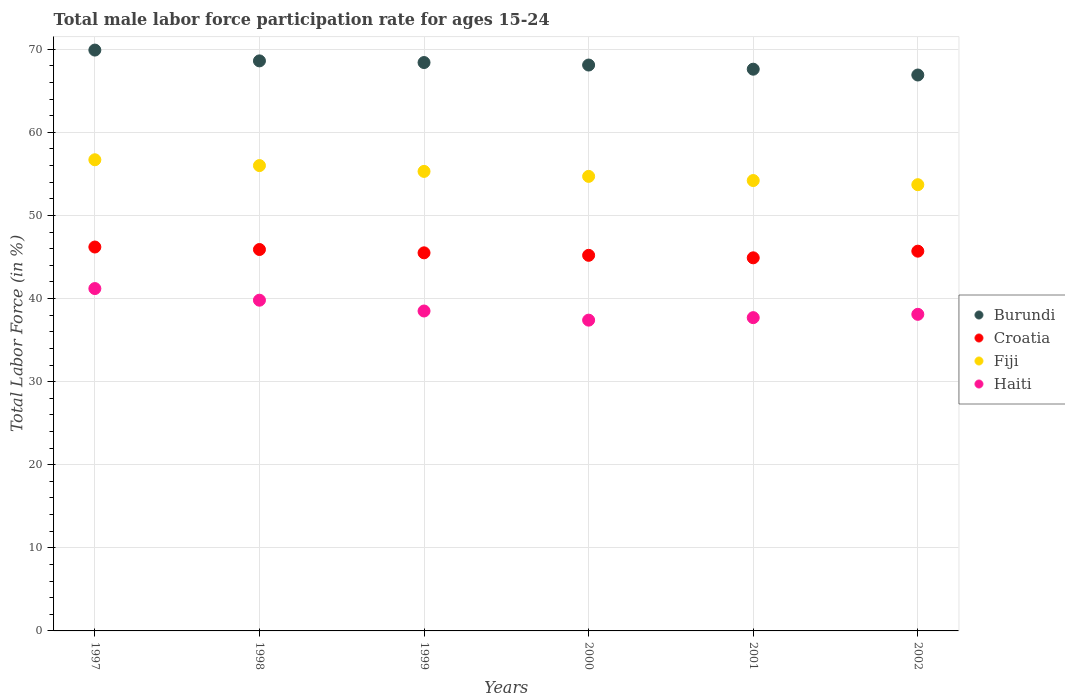What is the male labor force participation rate in Croatia in 2001?
Give a very brief answer. 44.9. Across all years, what is the maximum male labor force participation rate in Haiti?
Your answer should be compact. 41.2. Across all years, what is the minimum male labor force participation rate in Croatia?
Keep it short and to the point. 44.9. In which year was the male labor force participation rate in Fiji minimum?
Your response must be concise. 2002. What is the total male labor force participation rate in Fiji in the graph?
Make the answer very short. 330.6. What is the difference between the male labor force participation rate in Haiti in 1997 and that in 2000?
Provide a short and direct response. 3.8. What is the difference between the male labor force participation rate in Croatia in 2002 and the male labor force participation rate in Haiti in 1999?
Offer a very short reply. 7.2. What is the average male labor force participation rate in Burundi per year?
Provide a short and direct response. 68.25. In the year 2000, what is the difference between the male labor force participation rate in Haiti and male labor force participation rate in Croatia?
Provide a short and direct response. -7.8. What is the ratio of the male labor force participation rate in Haiti in 1997 to that in 1998?
Provide a succinct answer. 1.04. Is the difference between the male labor force participation rate in Haiti in 1999 and 2001 greater than the difference between the male labor force participation rate in Croatia in 1999 and 2001?
Offer a terse response. Yes. What is the difference between the highest and the second highest male labor force participation rate in Burundi?
Your answer should be compact. 1.3. What is the difference between the highest and the lowest male labor force participation rate in Burundi?
Make the answer very short. 3. In how many years, is the male labor force participation rate in Burundi greater than the average male labor force participation rate in Burundi taken over all years?
Your answer should be very brief. 3. Is the sum of the male labor force participation rate in Croatia in 1997 and 2000 greater than the maximum male labor force participation rate in Burundi across all years?
Your response must be concise. Yes. Does the male labor force participation rate in Burundi monotonically increase over the years?
Your answer should be compact. No. What is the difference between two consecutive major ticks on the Y-axis?
Your answer should be very brief. 10. How many legend labels are there?
Keep it short and to the point. 4. What is the title of the graph?
Make the answer very short. Total male labor force participation rate for ages 15-24. Does "Puerto Rico" appear as one of the legend labels in the graph?
Your answer should be compact. No. What is the label or title of the X-axis?
Provide a short and direct response. Years. What is the label or title of the Y-axis?
Keep it short and to the point. Total Labor Force (in %). What is the Total Labor Force (in %) of Burundi in 1997?
Provide a short and direct response. 69.9. What is the Total Labor Force (in %) in Croatia in 1997?
Keep it short and to the point. 46.2. What is the Total Labor Force (in %) of Fiji in 1997?
Provide a succinct answer. 56.7. What is the Total Labor Force (in %) in Haiti in 1997?
Provide a succinct answer. 41.2. What is the Total Labor Force (in %) of Burundi in 1998?
Ensure brevity in your answer.  68.6. What is the Total Labor Force (in %) in Croatia in 1998?
Offer a very short reply. 45.9. What is the Total Labor Force (in %) in Haiti in 1998?
Provide a succinct answer. 39.8. What is the Total Labor Force (in %) in Burundi in 1999?
Provide a succinct answer. 68.4. What is the Total Labor Force (in %) in Croatia in 1999?
Offer a very short reply. 45.5. What is the Total Labor Force (in %) in Fiji in 1999?
Keep it short and to the point. 55.3. What is the Total Labor Force (in %) in Haiti in 1999?
Make the answer very short. 38.5. What is the Total Labor Force (in %) of Burundi in 2000?
Make the answer very short. 68.1. What is the Total Labor Force (in %) in Croatia in 2000?
Offer a terse response. 45.2. What is the Total Labor Force (in %) in Fiji in 2000?
Offer a terse response. 54.7. What is the Total Labor Force (in %) in Haiti in 2000?
Give a very brief answer. 37.4. What is the Total Labor Force (in %) in Burundi in 2001?
Your answer should be compact. 67.6. What is the Total Labor Force (in %) of Croatia in 2001?
Keep it short and to the point. 44.9. What is the Total Labor Force (in %) in Fiji in 2001?
Provide a short and direct response. 54.2. What is the Total Labor Force (in %) of Haiti in 2001?
Offer a very short reply. 37.7. What is the Total Labor Force (in %) of Burundi in 2002?
Your answer should be very brief. 66.9. What is the Total Labor Force (in %) in Croatia in 2002?
Your answer should be very brief. 45.7. What is the Total Labor Force (in %) of Fiji in 2002?
Provide a succinct answer. 53.7. What is the Total Labor Force (in %) of Haiti in 2002?
Your answer should be very brief. 38.1. Across all years, what is the maximum Total Labor Force (in %) in Burundi?
Make the answer very short. 69.9. Across all years, what is the maximum Total Labor Force (in %) of Croatia?
Give a very brief answer. 46.2. Across all years, what is the maximum Total Labor Force (in %) of Fiji?
Your answer should be compact. 56.7. Across all years, what is the maximum Total Labor Force (in %) of Haiti?
Make the answer very short. 41.2. Across all years, what is the minimum Total Labor Force (in %) in Burundi?
Offer a terse response. 66.9. Across all years, what is the minimum Total Labor Force (in %) of Croatia?
Ensure brevity in your answer.  44.9. Across all years, what is the minimum Total Labor Force (in %) in Fiji?
Provide a succinct answer. 53.7. Across all years, what is the minimum Total Labor Force (in %) in Haiti?
Offer a very short reply. 37.4. What is the total Total Labor Force (in %) in Burundi in the graph?
Provide a short and direct response. 409.5. What is the total Total Labor Force (in %) of Croatia in the graph?
Your answer should be very brief. 273.4. What is the total Total Labor Force (in %) of Fiji in the graph?
Provide a succinct answer. 330.6. What is the total Total Labor Force (in %) in Haiti in the graph?
Offer a terse response. 232.7. What is the difference between the Total Labor Force (in %) in Burundi in 1997 and that in 1998?
Give a very brief answer. 1.3. What is the difference between the Total Labor Force (in %) in Haiti in 1997 and that in 1998?
Keep it short and to the point. 1.4. What is the difference between the Total Labor Force (in %) of Haiti in 1997 and that in 1999?
Keep it short and to the point. 2.7. What is the difference between the Total Labor Force (in %) of Croatia in 1997 and that in 2000?
Your response must be concise. 1. What is the difference between the Total Labor Force (in %) in Haiti in 1997 and that in 2000?
Provide a short and direct response. 3.8. What is the difference between the Total Labor Force (in %) of Fiji in 1997 and that in 2001?
Provide a succinct answer. 2.5. What is the difference between the Total Labor Force (in %) of Burundi in 1997 and that in 2002?
Provide a short and direct response. 3. What is the difference between the Total Labor Force (in %) of Burundi in 1998 and that in 1999?
Offer a very short reply. 0.2. What is the difference between the Total Labor Force (in %) of Fiji in 1998 and that in 1999?
Offer a terse response. 0.7. What is the difference between the Total Labor Force (in %) in Haiti in 1998 and that in 1999?
Provide a succinct answer. 1.3. What is the difference between the Total Labor Force (in %) in Croatia in 1998 and that in 2000?
Offer a terse response. 0.7. What is the difference between the Total Labor Force (in %) in Fiji in 1998 and that in 2001?
Offer a terse response. 1.8. What is the difference between the Total Labor Force (in %) of Haiti in 1998 and that in 2002?
Provide a short and direct response. 1.7. What is the difference between the Total Labor Force (in %) of Burundi in 1999 and that in 2000?
Offer a terse response. 0.3. What is the difference between the Total Labor Force (in %) of Fiji in 1999 and that in 2000?
Offer a terse response. 0.6. What is the difference between the Total Labor Force (in %) of Haiti in 1999 and that in 2000?
Your response must be concise. 1.1. What is the difference between the Total Labor Force (in %) of Haiti in 1999 and that in 2001?
Provide a short and direct response. 0.8. What is the difference between the Total Labor Force (in %) of Burundi in 1999 and that in 2002?
Offer a terse response. 1.5. What is the difference between the Total Labor Force (in %) in Haiti in 1999 and that in 2002?
Make the answer very short. 0.4. What is the difference between the Total Labor Force (in %) of Haiti in 2000 and that in 2001?
Your answer should be compact. -0.3. What is the difference between the Total Labor Force (in %) in Burundi in 2000 and that in 2002?
Give a very brief answer. 1.2. What is the difference between the Total Labor Force (in %) in Burundi in 2001 and that in 2002?
Your response must be concise. 0.7. What is the difference between the Total Labor Force (in %) in Croatia in 2001 and that in 2002?
Provide a short and direct response. -0.8. What is the difference between the Total Labor Force (in %) of Haiti in 2001 and that in 2002?
Make the answer very short. -0.4. What is the difference between the Total Labor Force (in %) of Burundi in 1997 and the Total Labor Force (in %) of Haiti in 1998?
Keep it short and to the point. 30.1. What is the difference between the Total Labor Force (in %) of Croatia in 1997 and the Total Labor Force (in %) of Haiti in 1998?
Give a very brief answer. 6.4. What is the difference between the Total Labor Force (in %) of Fiji in 1997 and the Total Labor Force (in %) of Haiti in 1998?
Ensure brevity in your answer.  16.9. What is the difference between the Total Labor Force (in %) in Burundi in 1997 and the Total Labor Force (in %) in Croatia in 1999?
Your answer should be very brief. 24.4. What is the difference between the Total Labor Force (in %) in Burundi in 1997 and the Total Labor Force (in %) in Haiti in 1999?
Provide a succinct answer. 31.4. What is the difference between the Total Labor Force (in %) in Croatia in 1997 and the Total Labor Force (in %) in Haiti in 1999?
Keep it short and to the point. 7.7. What is the difference between the Total Labor Force (in %) of Burundi in 1997 and the Total Labor Force (in %) of Croatia in 2000?
Ensure brevity in your answer.  24.7. What is the difference between the Total Labor Force (in %) in Burundi in 1997 and the Total Labor Force (in %) in Haiti in 2000?
Make the answer very short. 32.5. What is the difference between the Total Labor Force (in %) of Croatia in 1997 and the Total Labor Force (in %) of Haiti in 2000?
Give a very brief answer. 8.8. What is the difference between the Total Labor Force (in %) of Fiji in 1997 and the Total Labor Force (in %) of Haiti in 2000?
Offer a very short reply. 19.3. What is the difference between the Total Labor Force (in %) of Burundi in 1997 and the Total Labor Force (in %) of Fiji in 2001?
Provide a short and direct response. 15.7. What is the difference between the Total Labor Force (in %) in Burundi in 1997 and the Total Labor Force (in %) in Haiti in 2001?
Ensure brevity in your answer.  32.2. What is the difference between the Total Labor Force (in %) of Croatia in 1997 and the Total Labor Force (in %) of Fiji in 2001?
Your answer should be compact. -8. What is the difference between the Total Labor Force (in %) in Croatia in 1997 and the Total Labor Force (in %) in Haiti in 2001?
Make the answer very short. 8.5. What is the difference between the Total Labor Force (in %) of Fiji in 1997 and the Total Labor Force (in %) of Haiti in 2001?
Keep it short and to the point. 19. What is the difference between the Total Labor Force (in %) of Burundi in 1997 and the Total Labor Force (in %) of Croatia in 2002?
Provide a short and direct response. 24.2. What is the difference between the Total Labor Force (in %) in Burundi in 1997 and the Total Labor Force (in %) in Fiji in 2002?
Keep it short and to the point. 16.2. What is the difference between the Total Labor Force (in %) in Burundi in 1997 and the Total Labor Force (in %) in Haiti in 2002?
Keep it short and to the point. 31.8. What is the difference between the Total Labor Force (in %) in Croatia in 1997 and the Total Labor Force (in %) in Haiti in 2002?
Provide a succinct answer. 8.1. What is the difference between the Total Labor Force (in %) of Fiji in 1997 and the Total Labor Force (in %) of Haiti in 2002?
Keep it short and to the point. 18.6. What is the difference between the Total Labor Force (in %) of Burundi in 1998 and the Total Labor Force (in %) of Croatia in 1999?
Ensure brevity in your answer.  23.1. What is the difference between the Total Labor Force (in %) of Burundi in 1998 and the Total Labor Force (in %) of Haiti in 1999?
Keep it short and to the point. 30.1. What is the difference between the Total Labor Force (in %) of Croatia in 1998 and the Total Labor Force (in %) of Haiti in 1999?
Ensure brevity in your answer.  7.4. What is the difference between the Total Labor Force (in %) of Burundi in 1998 and the Total Labor Force (in %) of Croatia in 2000?
Your answer should be very brief. 23.4. What is the difference between the Total Labor Force (in %) of Burundi in 1998 and the Total Labor Force (in %) of Fiji in 2000?
Offer a very short reply. 13.9. What is the difference between the Total Labor Force (in %) of Burundi in 1998 and the Total Labor Force (in %) of Haiti in 2000?
Offer a very short reply. 31.2. What is the difference between the Total Labor Force (in %) in Croatia in 1998 and the Total Labor Force (in %) in Haiti in 2000?
Your answer should be compact. 8.5. What is the difference between the Total Labor Force (in %) in Fiji in 1998 and the Total Labor Force (in %) in Haiti in 2000?
Offer a terse response. 18.6. What is the difference between the Total Labor Force (in %) in Burundi in 1998 and the Total Labor Force (in %) in Croatia in 2001?
Give a very brief answer. 23.7. What is the difference between the Total Labor Force (in %) in Burundi in 1998 and the Total Labor Force (in %) in Fiji in 2001?
Ensure brevity in your answer.  14.4. What is the difference between the Total Labor Force (in %) of Burundi in 1998 and the Total Labor Force (in %) of Haiti in 2001?
Provide a succinct answer. 30.9. What is the difference between the Total Labor Force (in %) in Croatia in 1998 and the Total Labor Force (in %) in Haiti in 2001?
Make the answer very short. 8.2. What is the difference between the Total Labor Force (in %) in Burundi in 1998 and the Total Labor Force (in %) in Croatia in 2002?
Keep it short and to the point. 22.9. What is the difference between the Total Labor Force (in %) in Burundi in 1998 and the Total Labor Force (in %) in Haiti in 2002?
Keep it short and to the point. 30.5. What is the difference between the Total Labor Force (in %) of Croatia in 1998 and the Total Labor Force (in %) of Fiji in 2002?
Provide a succinct answer. -7.8. What is the difference between the Total Labor Force (in %) in Fiji in 1998 and the Total Labor Force (in %) in Haiti in 2002?
Keep it short and to the point. 17.9. What is the difference between the Total Labor Force (in %) of Burundi in 1999 and the Total Labor Force (in %) of Croatia in 2000?
Your response must be concise. 23.2. What is the difference between the Total Labor Force (in %) in Fiji in 1999 and the Total Labor Force (in %) in Haiti in 2000?
Your answer should be very brief. 17.9. What is the difference between the Total Labor Force (in %) of Burundi in 1999 and the Total Labor Force (in %) of Croatia in 2001?
Your answer should be very brief. 23.5. What is the difference between the Total Labor Force (in %) of Burundi in 1999 and the Total Labor Force (in %) of Fiji in 2001?
Offer a terse response. 14.2. What is the difference between the Total Labor Force (in %) of Burundi in 1999 and the Total Labor Force (in %) of Haiti in 2001?
Your answer should be very brief. 30.7. What is the difference between the Total Labor Force (in %) of Croatia in 1999 and the Total Labor Force (in %) of Haiti in 2001?
Make the answer very short. 7.8. What is the difference between the Total Labor Force (in %) in Fiji in 1999 and the Total Labor Force (in %) in Haiti in 2001?
Make the answer very short. 17.6. What is the difference between the Total Labor Force (in %) in Burundi in 1999 and the Total Labor Force (in %) in Croatia in 2002?
Provide a short and direct response. 22.7. What is the difference between the Total Labor Force (in %) in Burundi in 1999 and the Total Labor Force (in %) in Haiti in 2002?
Provide a succinct answer. 30.3. What is the difference between the Total Labor Force (in %) of Burundi in 2000 and the Total Labor Force (in %) of Croatia in 2001?
Make the answer very short. 23.2. What is the difference between the Total Labor Force (in %) of Burundi in 2000 and the Total Labor Force (in %) of Haiti in 2001?
Make the answer very short. 30.4. What is the difference between the Total Labor Force (in %) in Croatia in 2000 and the Total Labor Force (in %) in Fiji in 2001?
Ensure brevity in your answer.  -9. What is the difference between the Total Labor Force (in %) in Croatia in 2000 and the Total Labor Force (in %) in Haiti in 2001?
Provide a succinct answer. 7.5. What is the difference between the Total Labor Force (in %) in Burundi in 2000 and the Total Labor Force (in %) in Croatia in 2002?
Keep it short and to the point. 22.4. What is the difference between the Total Labor Force (in %) in Burundi in 2000 and the Total Labor Force (in %) in Fiji in 2002?
Make the answer very short. 14.4. What is the difference between the Total Labor Force (in %) in Burundi in 2000 and the Total Labor Force (in %) in Haiti in 2002?
Your answer should be very brief. 30. What is the difference between the Total Labor Force (in %) in Burundi in 2001 and the Total Labor Force (in %) in Croatia in 2002?
Your answer should be very brief. 21.9. What is the difference between the Total Labor Force (in %) of Burundi in 2001 and the Total Labor Force (in %) of Haiti in 2002?
Provide a short and direct response. 29.5. What is the difference between the Total Labor Force (in %) in Croatia in 2001 and the Total Labor Force (in %) in Fiji in 2002?
Your response must be concise. -8.8. What is the average Total Labor Force (in %) in Burundi per year?
Make the answer very short. 68.25. What is the average Total Labor Force (in %) of Croatia per year?
Your answer should be very brief. 45.57. What is the average Total Labor Force (in %) of Fiji per year?
Offer a terse response. 55.1. What is the average Total Labor Force (in %) of Haiti per year?
Provide a short and direct response. 38.78. In the year 1997, what is the difference between the Total Labor Force (in %) in Burundi and Total Labor Force (in %) in Croatia?
Offer a terse response. 23.7. In the year 1997, what is the difference between the Total Labor Force (in %) in Burundi and Total Labor Force (in %) in Haiti?
Your response must be concise. 28.7. In the year 1997, what is the difference between the Total Labor Force (in %) of Croatia and Total Labor Force (in %) of Fiji?
Offer a terse response. -10.5. In the year 1997, what is the difference between the Total Labor Force (in %) of Croatia and Total Labor Force (in %) of Haiti?
Give a very brief answer. 5. In the year 1998, what is the difference between the Total Labor Force (in %) of Burundi and Total Labor Force (in %) of Croatia?
Your response must be concise. 22.7. In the year 1998, what is the difference between the Total Labor Force (in %) in Burundi and Total Labor Force (in %) in Fiji?
Ensure brevity in your answer.  12.6. In the year 1998, what is the difference between the Total Labor Force (in %) of Burundi and Total Labor Force (in %) of Haiti?
Keep it short and to the point. 28.8. In the year 1998, what is the difference between the Total Labor Force (in %) of Croatia and Total Labor Force (in %) of Fiji?
Keep it short and to the point. -10.1. In the year 1998, what is the difference between the Total Labor Force (in %) in Croatia and Total Labor Force (in %) in Haiti?
Make the answer very short. 6.1. In the year 1999, what is the difference between the Total Labor Force (in %) in Burundi and Total Labor Force (in %) in Croatia?
Provide a succinct answer. 22.9. In the year 1999, what is the difference between the Total Labor Force (in %) in Burundi and Total Labor Force (in %) in Fiji?
Provide a succinct answer. 13.1. In the year 1999, what is the difference between the Total Labor Force (in %) in Burundi and Total Labor Force (in %) in Haiti?
Your answer should be compact. 29.9. In the year 1999, what is the difference between the Total Labor Force (in %) of Croatia and Total Labor Force (in %) of Fiji?
Your answer should be compact. -9.8. In the year 1999, what is the difference between the Total Labor Force (in %) in Fiji and Total Labor Force (in %) in Haiti?
Make the answer very short. 16.8. In the year 2000, what is the difference between the Total Labor Force (in %) of Burundi and Total Labor Force (in %) of Croatia?
Your answer should be very brief. 22.9. In the year 2000, what is the difference between the Total Labor Force (in %) of Burundi and Total Labor Force (in %) of Fiji?
Ensure brevity in your answer.  13.4. In the year 2000, what is the difference between the Total Labor Force (in %) of Burundi and Total Labor Force (in %) of Haiti?
Give a very brief answer. 30.7. In the year 2000, what is the difference between the Total Labor Force (in %) of Croatia and Total Labor Force (in %) of Haiti?
Give a very brief answer. 7.8. In the year 2001, what is the difference between the Total Labor Force (in %) in Burundi and Total Labor Force (in %) in Croatia?
Provide a succinct answer. 22.7. In the year 2001, what is the difference between the Total Labor Force (in %) of Burundi and Total Labor Force (in %) of Fiji?
Your answer should be compact. 13.4. In the year 2001, what is the difference between the Total Labor Force (in %) of Burundi and Total Labor Force (in %) of Haiti?
Ensure brevity in your answer.  29.9. In the year 2001, what is the difference between the Total Labor Force (in %) of Croatia and Total Labor Force (in %) of Fiji?
Provide a succinct answer. -9.3. In the year 2002, what is the difference between the Total Labor Force (in %) in Burundi and Total Labor Force (in %) in Croatia?
Your response must be concise. 21.2. In the year 2002, what is the difference between the Total Labor Force (in %) in Burundi and Total Labor Force (in %) in Fiji?
Provide a short and direct response. 13.2. In the year 2002, what is the difference between the Total Labor Force (in %) in Burundi and Total Labor Force (in %) in Haiti?
Ensure brevity in your answer.  28.8. In the year 2002, what is the difference between the Total Labor Force (in %) of Fiji and Total Labor Force (in %) of Haiti?
Ensure brevity in your answer.  15.6. What is the ratio of the Total Labor Force (in %) in Croatia in 1997 to that in 1998?
Your answer should be very brief. 1.01. What is the ratio of the Total Labor Force (in %) in Fiji in 1997 to that in 1998?
Ensure brevity in your answer.  1.01. What is the ratio of the Total Labor Force (in %) in Haiti in 1997 to that in 1998?
Your answer should be very brief. 1.04. What is the ratio of the Total Labor Force (in %) of Burundi in 1997 to that in 1999?
Provide a succinct answer. 1.02. What is the ratio of the Total Labor Force (in %) in Croatia in 1997 to that in 1999?
Provide a short and direct response. 1.02. What is the ratio of the Total Labor Force (in %) of Fiji in 1997 to that in 1999?
Provide a succinct answer. 1.03. What is the ratio of the Total Labor Force (in %) in Haiti in 1997 to that in 1999?
Ensure brevity in your answer.  1.07. What is the ratio of the Total Labor Force (in %) of Burundi in 1997 to that in 2000?
Provide a short and direct response. 1.03. What is the ratio of the Total Labor Force (in %) in Croatia in 1997 to that in 2000?
Offer a very short reply. 1.02. What is the ratio of the Total Labor Force (in %) in Fiji in 1997 to that in 2000?
Make the answer very short. 1.04. What is the ratio of the Total Labor Force (in %) in Haiti in 1997 to that in 2000?
Your answer should be very brief. 1.1. What is the ratio of the Total Labor Force (in %) in Burundi in 1997 to that in 2001?
Your answer should be compact. 1.03. What is the ratio of the Total Labor Force (in %) in Fiji in 1997 to that in 2001?
Make the answer very short. 1.05. What is the ratio of the Total Labor Force (in %) in Haiti in 1997 to that in 2001?
Make the answer very short. 1.09. What is the ratio of the Total Labor Force (in %) in Burundi in 1997 to that in 2002?
Your answer should be compact. 1.04. What is the ratio of the Total Labor Force (in %) in Croatia in 1997 to that in 2002?
Your response must be concise. 1.01. What is the ratio of the Total Labor Force (in %) in Fiji in 1997 to that in 2002?
Provide a succinct answer. 1.06. What is the ratio of the Total Labor Force (in %) of Haiti in 1997 to that in 2002?
Your response must be concise. 1.08. What is the ratio of the Total Labor Force (in %) in Croatia in 1998 to that in 1999?
Make the answer very short. 1.01. What is the ratio of the Total Labor Force (in %) of Fiji in 1998 to that in 1999?
Give a very brief answer. 1.01. What is the ratio of the Total Labor Force (in %) of Haiti in 1998 to that in 1999?
Your answer should be compact. 1.03. What is the ratio of the Total Labor Force (in %) of Burundi in 1998 to that in 2000?
Your response must be concise. 1.01. What is the ratio of the Total Labor Force (in %) in Croatia in 1998 to that in 2000?
Your answer should be very brief. 1.02. What is the ratio of the Total Labor Force (in %) in Fiji in 1998 to that in 2000?
Offer a very short reply. 1.02. What is the ratio of the Total Labor Force (in %) of Haiti in 1998 to that in 2000?
Provide a short and direct response. 1.06. What is the ratio of the Total Labor Force (in %) of Burundi in 1998 to that in 2001?
Ensure brevity in your answer.  1.01. What is the ratio of the Total Labor Force (in %) in Croatia in 1998 to that in 2001?
Make the answer very short. 1.02. What is the ratio of the Total Labor Force (in %) in Fiji in 1998 to that in 2001?
Your answer should be compact. 1.03. What is the ratio of the Total Labor Force (in %) of Haiti in 1998 to that in 2001?
Ensure brevity in your answer.  1.06. What is the ratio of the Total Labor Force (in %) in Burundi in 1998 to that in 2002?
Provide a succinct answer. 1.03. What is the ratio of the Total Labor Force (in %) in Fiji in 1998 to that in 2002?
Provide a short and direct response. 1.04. What is the ratio of the Total Labor Force (in %) in Haiti in 1998 to that in 2002?
Your response must be concise. 1.04. What is the ratio of the Total Labor Force (in %) in Croatia in 1999 to that in 2000?
Ensure brevity in your answer.  1.01. What is the ratio of the Total Labor Force (in %) of Fiji in 1999 to that in 2000?
Your answer should be compact. 1.01. What is the ratio of the Total Labor Force (in %) of Haiti in 1999 to that in 2000?
Make the answer very short. 1.03. What is the ratio of the Total Labor Force (in %) of Burundi in 1999 to that in 2001?
Provide a succinct answer. 1.01. What is the ratio of the Total Labor Force (in %) in Croatia in 1999 to that in 2001?
Your response must be concise. 1.01. What is the ratio of the Total Labor Force (in %) of Fiji in 1999 to that in 2001?
Keep it short and to the point. 1.02. What is the ratio of the Total Labor Force (in %) in Haiti in 1999 to that in 2001?
Offer a terse response. 1.02. What is the ratio of the Total Labor Force (in %) in Burundi in 1999 to that in 2002?
Offer a very short reply. 1.02. What is the ratio of the Total Labor Force (in %) of Croatia in 1999 to that in 2002?
Ensure brevity in your answer.  1. What is the ratio of the Total Labor Force (in %) of Fiji in 1999 to that in 2002?
Ensure brevity in your answer.  1.03. What is the ratio of the Total Labor Force (in %) in Haiti in 1999 to that in 2002?
Ensure brevity in your answer.  1.01. What is the ratio of the Total Labor Force (in %) of Burundi in 2000 to that in 2001?
Provide a short and direct response. 1.01. What is the ratio of the Total Labor Force (in %) in Croatia in 2000 to that in 2001?
Your answer should be very brief. 1.01. What is the ratio of the Total Labor Force (in %) in Fiji in 2000 to that in 2001?
Offer a very short reply. 1.01. What is the ratio of the Total Labor Force (in %) in Haiti in 2000 to that in 2001?
Ensure brevity in your answer.  0.99. What is the ratio of the Total Labor Force (in %) in Burundi in 2000 to that in 2002?
Make the answer very short. 1.02. What is the ratio of the Total Labor Force (in %) in Croatia in 2000 to that in 2002?
Make the answer very short. 0.99. What is the ratio of the Total Labor Force (in %) of Fiji in 2000 to that in 2002?
Keep it short and to the point. 1.02. What is the ratio of the Total Labor Force (in %) in Haiti in 2000 to that in 2002?
Keep it short and to the point. 0.98. What is the ratio of the Total Labor Force (in %) in Burundi in 2001 to that in 2002?
Offer a very short reply. 1.01. What is the ratio of the Total Labor Force (in %) of Croatia in 2001 to that in 2002?
Make the answer very short. 0.98. What is the ratio of the Total Labor Force (in %) of Fiji in 2001 to that in 2002?
Your answer should be very brief. 1.01. What is the ratio of the Total Labor Force (in %) in Haiti in 2001 to that in 2002?
Provide a succinct answer. 0.99. What is the difference between the highest and the second highest Total Labor Force (in %) in Burundi?
Keep it short and to the point. 1.3. What is the difference between the highest and the second highest Total Labor Force (in %) in Fiji?
Make the answer very short. 0.7. What is the difference between the highest and the lowest Total Labor Force (in %) of Croatia?
Provide a succinct answer. 1.3. 